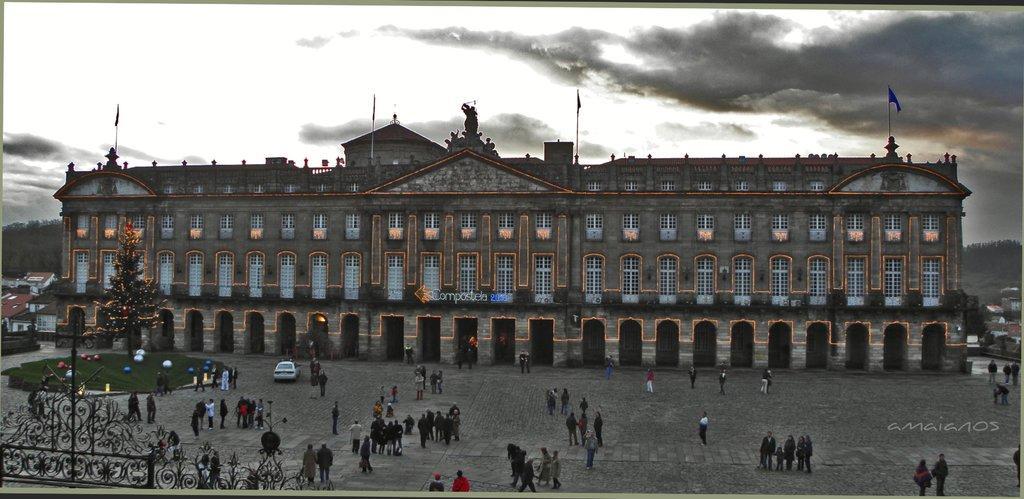Describe this image in one or two sentences. In this image we can a big building and it is a having many windows. There are many houses in the image. There are many people standing in many groups. There is a grassy land in the image. A car is parked in front of a building. There is a partly cloudy sky in the image. 